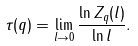<formula> <loc_0><loc_0><loc_500><loc_500>\tau ( q ) = \lim _ { l \rightarrow 0 } \frac { \ln Z _ { q } ( l ) } { \ln l } .</formula> 